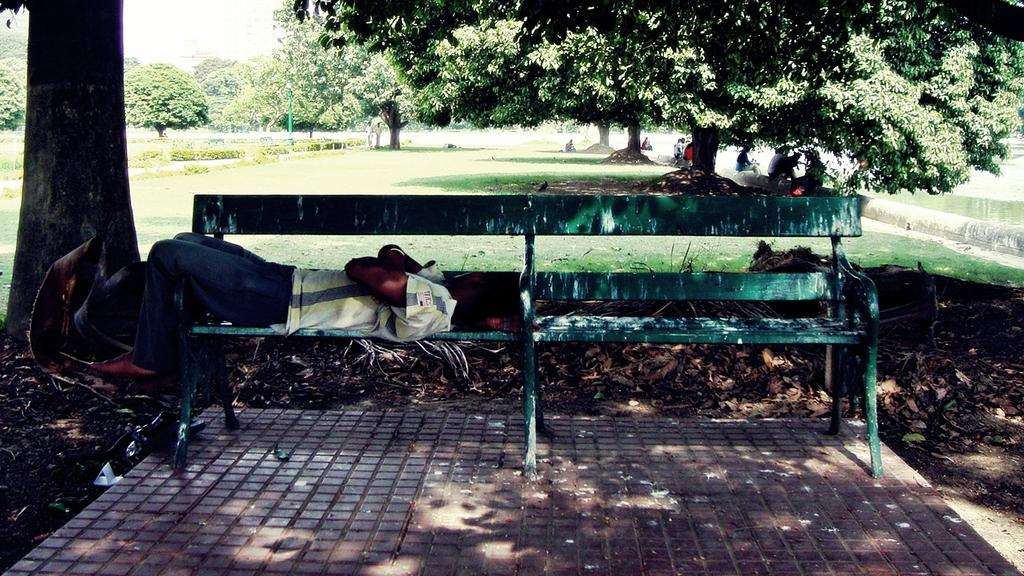What is the main object in the image? There is a table in the image. What is the man on the table doing? A man is sleeping on the table. What type of vegetation is present in the image? There is a tree and grass in the image. How many trees can be seen in the image? There is one tree and additional trees in the image. What language is the man speaking on the stage in the image? There is no stage or man speaking in the image; it only shows a table with a man sleeping on it, a tree, and grass. 